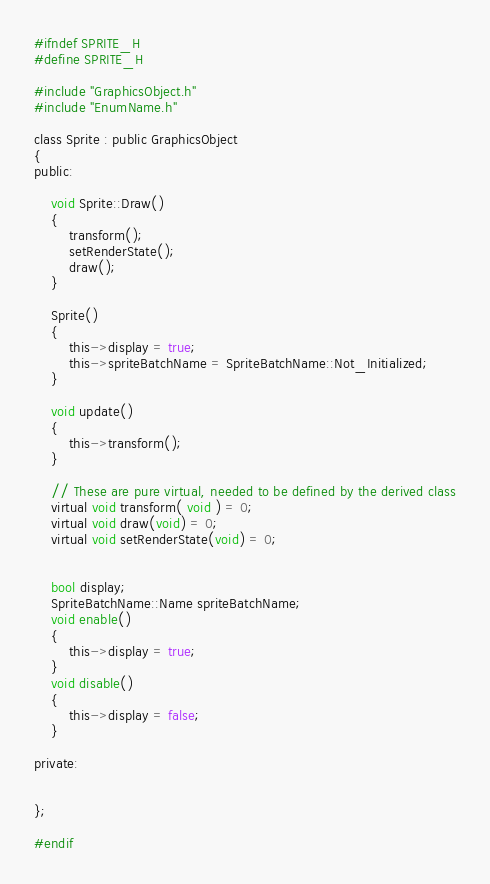<code> <loc_0><loc_0><loc_500><loc_500><_C_>#ifndef SPRITE_H
#define SPRITE_H

#include "GraphicsObject.h"
#include "EnumName.h"

class Sprite : public GraphicsObject
{
public:

	void Sprite::Draw()
	{
		transform();
		setRenderState();
		draw();
	}

	Sprite()
	{
		this->display = true;
		this->spriteBatchName = SpriteBatchName::Not_Initialized;
	}

	void update()
	{
		this->transform();
	}

	// These are pure virtual, needed to be defined by the derived class
	virtual void transform( void ) = 0;   
	virtual void draw(void) = 0;
	virtual void setRenderState(void) = 0;
	
	
	bool display;
	SpriteBatchName::Name spriteBatchName;
	void enable()
	{
		this->display = true;
	}
	void disable()
	{
		this->display = false;
	}

private:


};

#endif</code> 